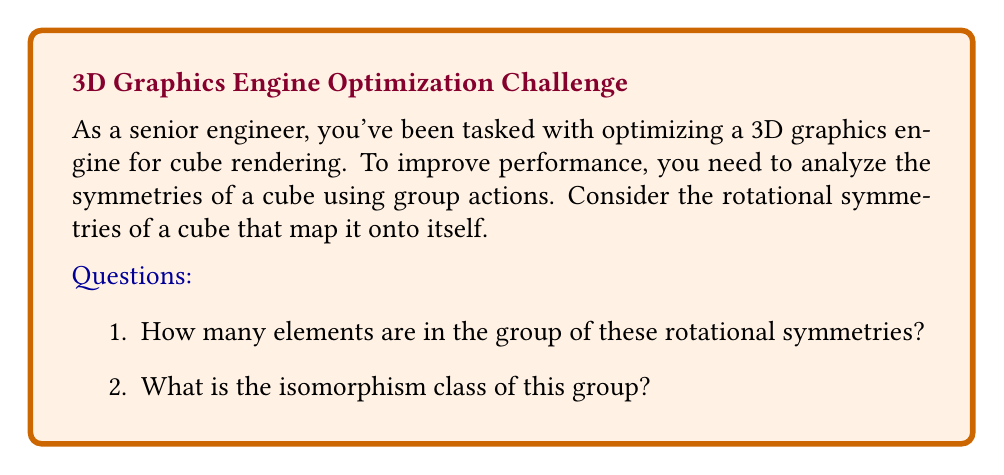Show me your answer to this math problem. Let's approach this step-by-step:

1) First, we need to identify the rotational symmetries of a cube:
   - Rotations around the axes through the centers of opposite faces (90°, 180°, 270°)
   - Rotations around the axes through opposite vertices (120°, 240°)
   - Rotations around the axes through the midpoints of opposite edges (180°)

2) Count the number of symmetries:
   - Face rotations: 3 axes × 3 rotations each = 9
   - Vertex rotations: 4 axes × 2 rotations each = 8
   - Edge rotations: 6 axes × 1 rotation each = 6
   - Identity rotation = 1

3) Total number of rotational symmetries: 9 + 8 + 6 + 1 = 24

4) To determine the isomorphism class, we need to recognize that these rotations form a group under composition. This group is isomorphic to the octahedral group, which is in turn isomorphic to $S_4$, the symmetric group on 4 elements.

5) We can see this isomorphism by considering how the rotations permute the four long diagonals of the cube (from one vertex to the opposite vertex).

6) The structure of this group:
   - Order: 24
   - Non-abelian
   - Contains elements of orders 1, 2, 3, and 4

These properties uniquely identify it as isomorphic to $S_4$.
Answer: 24 elements; isomorphic to $S_4$ 